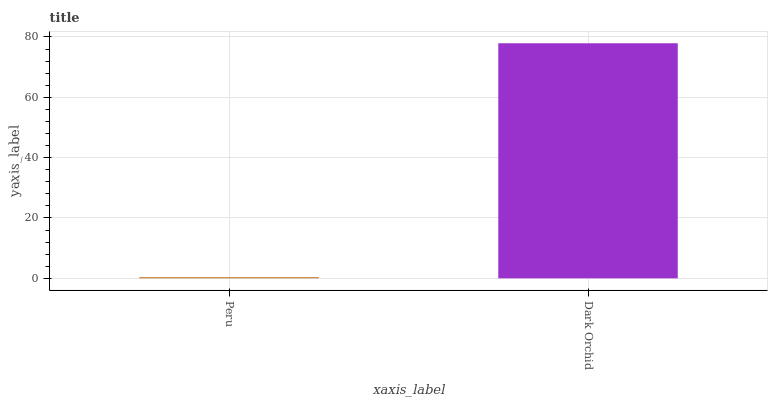Is Dark Orchid the minimum?
Answer yes or no. No. Is Dark Orchid greater than Peru?
Answer yes or no. Yes. Is Peru less than Dark Orchid?
Answer yes or no. Yes. Is Peru greater than Dark Orchid?
Answer yes or no. No. Is Dark Orchid less than Peru?
Answer yes or no. No. Is Dark Orchid the high median?
Answer yes or no. Yes. Is Peru the low median?
Answer yes or no. Yes. Is Peru the high median?
Answer yes or no. No. Is Dark Orchid the low median?
Answer yes or no. No. 